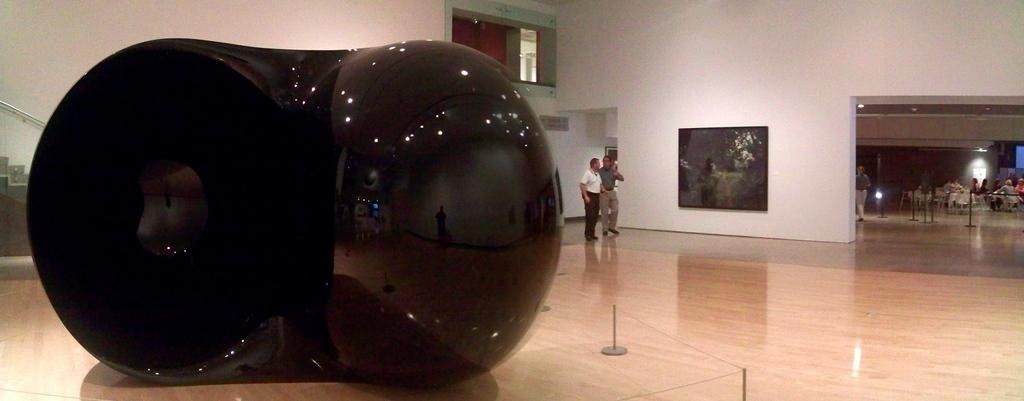What is the main object in the foreground of the image? There is a black color object in the foreground of the image. What can be seen in the background of the image? There are people, lamps, chairs, and other objects in the background of the image. Can you tell me how many leaves are on the comb in the image? There is no comb or leaves present in the image. 